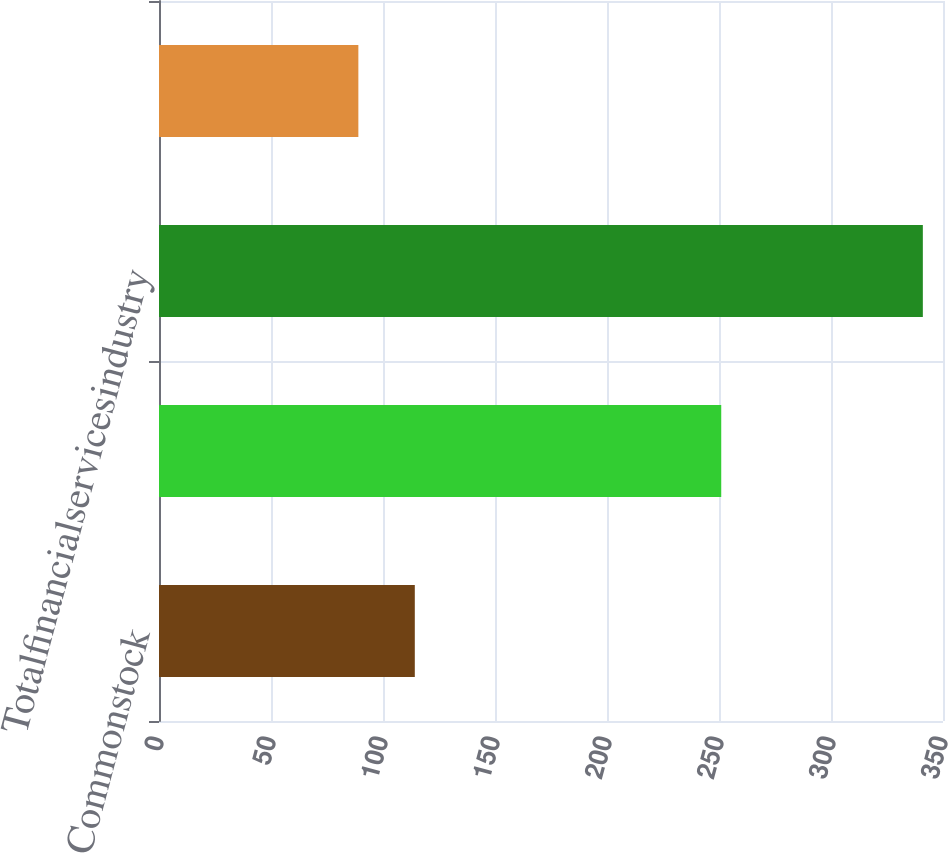Convert chart to OTSL. <chart><loc_0><loc_0><loc_500><loc_500><bar_chart><fcel>Commonstock<fcel>Unnamed: 1<fcel>Totalfinancialservicesindustry<fcel>Other<nl><fcel>114.2<fcel>251<fcel>341<fcel>89<nl></chart> 